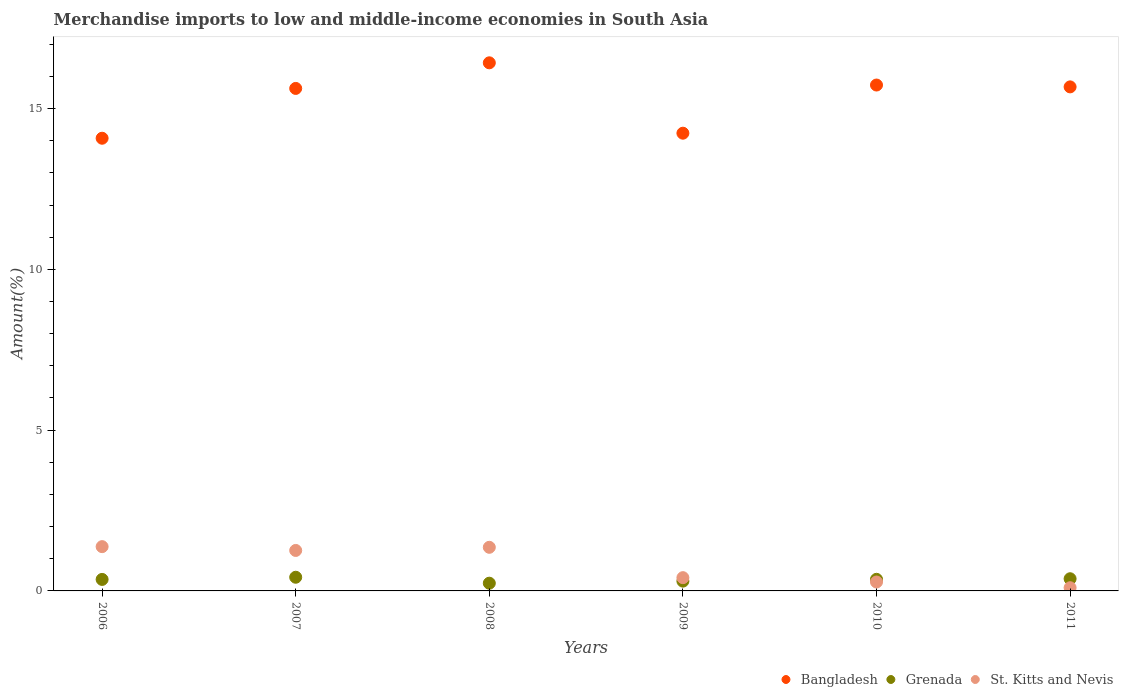Is the number of dotlines equal to the number of legend labels?
Make the answer very short. Yes. What is the percentage of amount earned from merchandise imports in Bangladesh in 2008?
Your answer should be compact. 16.42. Across all years, what is the maximum percentage of amount earned from merchandise imports in St. Kitts and Nevis?
Your response must be concise. 1.38. Across all years, what is the minimum percentage of amount earned from merchandise imports in St. Kitts and Nevis?
Provide a succinct answer. 0.1. In which year was the percentage of amount earned from merchandise imports in Bangladesh maximum?
Provide a succinct answer. 2008. What is the total percentage of amount earned from merchandise imports in Bangladesh in the graph?
Keep it short and to the point. 91.77. What is the difference between the percentage of amount earned from merchandise imports in St. Kitts and Nevis in 2006 and that in 2010?
Offer a very short reply. 1.1. What is the difference between the percentage of amount earned from merchandise imports in Grenada in 2011 and the percentage of amount earned from merchandise imports in St. Kitts and Nevis in 2008?
Keep it short and to the point. -0.98. What is the average percentage of amount earned from merchandise imports in Bangladesh per year?
Offer a very short reply. 15.3. In the year 2011, what is the difference between the percentage of amount earned from merchandise imports in Grenada and percentage of amount earned from merchandise imports in Bangladesh?
Keep it short and to the point. -15.3. In how many years, is the percentage of amount earned from merchandise imports in Grenada greater than 7 %?
Give a very brief answer. 0. What is the ratio of the percentage of amount earned from merchandise imports in St. Kitts and Nevis in 2007 to that in 2011?
Your response must be concise. 12.65. What is the difference between the highest and the second highest percentage of amount earned from merchandise imports in Bangladesh?
Your response must be concise. 0.69. What is the difference between the highest and the lowest percentage of amount earned from merchandise imports in St. Kitts and Nevis?
Provide a succinct answer. 1.28. In how many years, is the percentage of amount earned from merchandise imports in Bangladesh greater than the average percentage of amount earned from merchandise imports in Bangladesh taken over all years?
Give a very brief answer. 4. Is the sum of the percentage of amount earned from merchandise imports in St. Kitts and Nevis in 2006 and 2007 greater than the maximum percentage of amount earned from merchandise imports in Bangladesh across all years?
Your answer should be very brief. No. Is it the case that in every year, the sum of the percentage of amount earned from merchandise imports in St. Kitts and Nevis and percentage of amount earned from merchandise imports in Bangladesh  is greater than the percentage of amount earned from merchandise imports in Grenada?
Offer a very short reply. Yes. Are the values on the major ticks of Y-axis written in scientific E-notation?
Give a very brief answer. No. Does the graph contain any zero values?
Offer a very short reply. No. How many legend labels are there?
Your answer should be compact. 3. How are the legend labels stacked?
Offer a very short reply. Horizontal. What is the title of the graph?
Provide a short and direct response. Merchandise imports to low and middle-income economies in South Asia. What is the label or title of the Y-axis?
Provide a succinct answer. Amount(%). What is the Amount(%) in Bangladesh in 2006?
Ensure brevity in your answer.  14.08. What is the Amount(%) in Grenada in 2006?
Offer a terse response. 0.36. What is the Amount(%) in St. Kitts and Nevis in 2006?
Offer a very short reply. 1.38. What is the Amount(%) in Bangladesh in 2007?
Keep it short and to the point. 15.63. What is the Amount(%) of Grenada in 2007?
Your answer should be very brief. 0.43. What is the Amount(%) of St. Kitts and Nevis in 2007?
Offer a very short reply. 1.26. What is the Amount(%) of Bangladesh in 2008?
Your answer should be very brief. 16.42. What is the Amount(%) of Grenada in 2008?
Ensure brevity in your answer.  0.24. What is the Amount(%) of St. Kitts and Nevis in 2008?
Your answer should be compact. 1.36. What is the Amount(%) in Bangladesh in 2009?
Provide a short and direct response. 14.23. What is the Amount(%) in Grenada in 2009?
Your answer should be very brief. 0.3. What is the Amount(%) of St. Kitts and Nevis in 2009?
Give a very brief answer. 0.41. What is the Amount(%) of Bangladesh in 2010?
Your answer should be very brief. 15.73. What is the Amount(%) of Grenada in 2010?
Provide a short and direct response. 0.36. What is the Amount(%) of St. Kitts and Nevis in 2010?
Provide a succinct answer. 0.28. What is the Amount(%) of Bangladesh in 2011?
Provide a succinct answer. 15.68. What is the Amount(%) in Grenada in 2011?
Provide a succinct answer. 0.38. What is the Amount(%) in St. Kitts and Nevis in 2011?
Provide a short and direct response. 0.1. Across all years, what is the maximum Amount(%) in Bangladesh?
Offer a terse response. 16.42. Across all years, what is the maximum Amount(%) in Grenada?
Provide a short and direct response. 0.43. Across all years, what is the maximum Amount(%) of St. Kitts and Nevis?
Provide a succinct answer. 1.38. Across all years, what is the minimum Amount(%) in Bangladesh?
Keep it short and to the point. 14.08. Across all years, what is the minimum Amount(%) in Grenada?
Your answer should be very brief. 0.24. Across all years, what is the minimum Amount(%) of St. Kitts and Nevis?
Make the answer very short. 0.1. What is the total Amount(%) of Bangladesh in the graph?
Offer a terse response. 91.77. What is the total Amount(%) of Grenada in the graph?
Ensure brevity in your answer.  2.07. What is the total Amount(%) in St. Kitts and Nevis in the graph?
Keep it short and to the point. 4.78. What is the difference between the Amount(%) of Bangladesh in 2006 and that in 2007?
Your answer should be very brief. -1.55. What is the difference between the Amount(%) in Grenada in 2006 and that in 2007?
Your response must be concise. -0.07. What is the difference between the Amount(%) in St. Kitts and Nevis in 2006 and that in 2007?
Make the answer very short. 0.12. What is the difference between the Amount(%) of Bangladesh in 2006 and that in 2008?
Your answer should be compact. -2.35. What is the difference between the Amount(%) of Grenada in 2006 and that in 2008?
Your answer should be very brief. 0.12. What is the difference between the Amount(%) of St. Kitts and Nevis in 2006 and that in 2008?
Provide a short and direct response. 0.02. What is the difference between the Amount(%) in Bangladesh in 2006 and that in 2009?
Give a very brief answer. -0.16. What is the difference between the Amount(%) of Grenada in 2006 and that in 2009?
Your response must be concise. 0.05. What is the difference between the Amount(%) of St. Kitts and Nevis in 2006 and that in 2009?
Give a very brief answer. 0.96. What is the difference between the Amount(%) in Bangladesh in 2006 and that in 2010?
Provide a short and direct response. -1.65. What is the difference between the Amount(%) of Grenada in 2006 and that in 2010?
Your answer should be very brief. -0. What is the difference between the Amount(%) in St. Kitts and Nevis in 2006 and that in 2010?
Provide a succinct answer. 1.1. What is the difference between the Amount(%) of Bangladesh in 2006 and that in 2011?
Give a very brief answer. -1.6. What is the difference between the Amount(%) in Grenada in 2006 and that in 2011?
Your response must be concise. -0.02. What is the difference between the Amount(%) in St. Kitts and Nevis in 2006 and that in 2011?
Your answer should be very brief. 1.28. What is the difference between the Amount(%) in Bangladesh in 2007 and that in 2008?
Your answer should be very brief. -0.8. What is the difference between the Amount(%) of Grenada in 2007 and that in 2008?
Keep it short and to the point. 0.18. What is the difference between the Amount(%) in St. Kitts and Nevis in 2007 and that in 2008?
Your response must be concise. -0.1. What is the difference between the Amount(%) in Bangladesh in 2007 and that in 2009?
Your answer should be compact. 1.39. What is the difference between the Amount(%) in Grenada in 2007 and that in 2009?
Make the answer very short. 0.12. What is the difference between the Amount(%) in St. Kitts and Nevis in 2007 and that in 2009?
Your answer should be very brief. 0.85. What is the difference between the Amount(%) of Bangladesh in 2007 and that in 2010?
Your response must be concise. -0.11. What is the difference between the Amount(%) of Grenada in 2007 and that in 2010?
Provide a short and direct response. 0.06. What is the difference between the Amount(%) in St. Kitts and Nevis in 2007 and that in 2010?
Your answer should be compact. 0.98. What is the difference between the Amount(%) in Bangladesh in 2007 and that in 2011?
Provide a short and direct response. -0.05. What is the difference between the Amount(%) of Grenada in 2007 and that in 2011?
Make the answer very short. 0.05. What is the difference between the Amount(%) in St. Kitts and Nevis in 2007 and that in 2011?
Provide a short and direct response. 1.16. What is the difference between the Amount(%) of Bangladesh in 2008 and that in 2009?
Your response must be concise. 2.19. What is the difference between the Amount(%) in Grenada in 2008 and that in 2009?
Your response must be concise. -0.06. What is the difference between the Amount(%) of St. Kitts and Nevis in 2008 and that in 2009?
Offer a terse response. 0.94. What is the difference between the Amount(%) of Bangladesh in 2008 and that in 2010?
Offer a terse response. 0.69. What is the difference between the Amount(%) of Grenada in 2008 and that in 2010?
Your answer should be very brief. -0.12. What is the difference between the Amount(%) in St. Kitts and Nevis in 2008 and that in 2010?
Offer a very short reply. 1.08. What is the difference between the Amount(%) of Bangladesh in 2008 and that in 2011?
Ensure brevity in your answer.  0.75. What is the difference between the Amount(%) in Grenada in 2008 and that in 2011?
Your answer should be very brief. -0.14. What is the difference between the Amount(%) of St. Kitts and Nevis in 2008 and that in 2011?
Keep it short and to the point. 1.26. What is the difference between the Amount(%) of Bangladesh in 2009 and that in 2010?
Make the answer very short. -1.5. What is the difference between the Amount(%) of Grenada in 2009 and that in 2010?
Your answer should be compact. -0.06. What is the difference between the Amount(%) of St. Kitts and Nevis in 2009 and that in 2010?
Your answer should be very brief. 0.13. What is the difference between the Amount(%) of Bangladesh in 2009 and that in 2011?
Ensure brevity in your answer.  -1.44. What is the difference between the Amount(%) of Grenada in 2009 and that in 2011?
Ensure brevity in your answer.  -0.07. What is the difference between the Amount(%) of St. Kitts and Nevis in 2009 and that in 2011?
Make the answer very short. 0.31. What is the difference between the Amount(%) in Bangladesh in 2010 and that in 2011?
Offer a terse response. 0.06. What is the difference between the Amount(%) of Grenada in 2010 and that in 2011?
Your answer should be very brief. -0.02. What is the difference between the Amount(%) of St. Kitts and Nevis in 2010 and that in 2011?
Provide a short and direct response. 0.18. What is the difference between the Amount(%) in Bangladesh in 2006 and the Amount(%) in Grenada in 2007?
Ensure brevity in your answer.  13.65. What is the difference between the Amount(%) of Bangladesh in 2006 and the Amount(%) of St. Kitts and Nevis in 2007?
Keep it short and to the point. 12.82. What is the difference between the Amount(%) in Grenada in 2006 and the Amount(%) in St. Kitts and Nevis in 2007?
Ensure brevity in your answer.  -0.9. What is the difference between the Amount(%) in Bangladesh in 2006 and the Amount(%) in Grenada in 2008?
Offer a terse response. 13.84. What is the difference between the Amount(%) in Bangladesh in 2006 and the Amount(%) in St. Kitts and Nevis in 2008?
Offer a very short reply. 12.72. What is the difference between the Amount(%) of Grenada in 2006 and the Amount(%) of St. Kitts and Nevis in 2008?
Your answer should be very brief. -1. What is the difference between the Amount(%) in Bangladesh in 2006 and the Amount(%) in Grenada in 2009?
Offer a very short reply. 13.77. What is the difference between the Amount(%) in Bangladesh in 2006 and the Amount(%) in St. Kitts and Nevis in 2009?
Your answer should be very brief. 13.67. What is the difference between the Amount(%) in Grenada in 2006 and the Amount(%) in St. Kitts and Nevis in 2009?
Offer a terse response. -0.05. What is the difference between the Amount(%) of Bangladesh in 2006 and the Amount(%) of Grenada in 2010?
Offer a very short reply. 13.72. What is the difference between the Amount(%) of Bangladesh in 2006 and the Amount(%) of St. Kitts and Nevis in 2010?
Offer a very short reply. 13.8. What is the difference between the Amount(%) of Grenada in 2006 and the Amount(%) of St. Kitts and Nevis in 2010?
Your response must be concise. 0.08. What is the difference between the Amount(%) of Bangladesh in 2006 and the Amount(%) of Grenada in 2011?
Provide a short and direct response. 13.7. What is the difference between the Amount(%) of Bangladesh in 2006 and the Amount(%) of St. Kitts and Nevis in 2011?
Your answer should be very brief. 13.98. What is the difference between the Amount(%) of Grenada in 2006 and the Amount(%) of St. Kitts and Nevis in 2011?
Your response must be concise. 0.26. What is the difference between the Amount(%) in Bangladesh in 2007 and the Amount(%) in Grenada in 2008?
Provide a short and direct response. 15.39. What is the difference between the Amount(%) of Bangladesh in 2007 and the Amount(%) of St. Kitts and Nevis in 2008?
Give a very brief answer. 14.27. What is the difference between the Amount(%) of Grenada in 2007 and the Amount(%) of St. Kitts and Nevis in 2008?
Keep it short and to the point. -0.93. What is the difference between the Amount(%) of Bangladesh in 2007 and the Amount(%) of Grenada in 2009?
Your answer should be compact. 15.32. What is the difference between the Amount(%) of Bangladesh in 2007 and the Amount(%) of St. Kitts and Nevis in 2009?
Your answer should be very brief. 15.22. What is the difference between the Amount(%) in Grenada in 2007 and the Amount(%) in St. Kitts and Nevis in 2009?
Offer a terse response. 0.01. What is the difference between the Amount(%) of Bangladesh in 2007 and the Amount(%) of Grenada in 2010?
Offer a terse response. 15.27. What is the difference between the Amount(%) of Bangladesh in 2007 and the Amount(%) of St. Kitts and Nevis in 2010?
Your response must be concise. 15.35. What is the difference between the Amount(%) in Grenada in 2007 and the Amount(%) in St. Kitts and Nevis in 2010?
Your answer should be very brief. 0.15. What is the difference between the Amount(%) of Bangladesh in 2007 and the Amount(%) of Grenada in 2011?
Offer a terse response. 15.25. What is the difference between the Amount(%) in Bangladesh in 2007 and the Amount(%) in St. Kitts and Nevis in 2011?
Your answer should be very brief. 15.53. What is the difference between the Amount(%) in Grenada in 2007 and the Amount(%) in St. Kitts and Nevis in 2011?
Provide a succinct answer. 0.33. What is the difference between the Amount(%) of Bangladesh in 2008 and the Amount(%) of Grenada in 2009?
Provide a short and direct response. 16.12. What is the difference between the Amount(%) in Bangladesh in 2008 and the Amount(%) in St. Kitts and Nevis in 2009?
Give a very brief answer. 16.01. What is the difference between the Amount(%) of Grenada in 2008 and the Amount(%) of St. Kitts and Nevis in 2009?
Provide a short and direct response. -0.17. What is the difference between the Amount(%) of Bangladesh in 2008 and the Amount(%) of Grenada in 2010?
Keep it short and to the point. 16.06. What is the difference between the Amount(%) in Bangladesh in 2008 and the Amount(%) in St. Kitts and Nevis in 2010?
Provide a short and direct response. 16.15. What is the difference between the Amount(%) of Grenada in 2008 and the Amount(%) of St. Kitts and Nevis in 2010?
Provide a succinct answer. -0.04. What is the difference between the Amount(%) in Bangladesh in 2008 and the Amount(%) in Grenada in 2011?
Give a very brief answer. 16.04. What is the difference between the Amount(%) in Bangladesh in 2008 and the Amount(%) in St. Kitts and Nevis in 2011?
Your answer should be very brief. 16.32. What is the difference between the Amount(%) in Grenada in 2008 and the Amount(%) in St. Kitts and Nevis in 2011?
Ensure brevity in your answer.  0.14. What is the difference between the Amount(%) of Bangladesh in 2009 and the Amount(%) of Grenada in 2010?
Ensure brevity in your answer.  13.87. What is the difference between the Amount(%) in Bangladesh in 2009 and the Amount(%) in St. Kitts and Nevis in 2010?
Your response must be concise. 13.96. What is the difference between the Amount(%) in Grenada in 2009 and the Amount(%) in St. Kitts and Nevis in 2010?
Provide a succinct answer. 0.03. What is the difference between the Amount(%) of Bangladesh in 2009 and the Amount(%) of Grenada in 2011?
Your answer should be compact. 13.86. What is the difference between the Amount(%) in Bangladesh in 2009 and the Amount(%) in St. Kitts and Nevis in 2011?
Make the answer very short. 14.14. What is the difference between the Amount(%) of Grenada in 2009 and the Amount(%) of St. Kitts and Nevis in 2011?
Provide a short and direct response. 0.2. What is the difference between the Amount(%) of Bangladesh in 2010 and the Amount(%) of Grenada in 2011?
Ensure brevity in your answer.  15.35. What is the difference between the Amount(%) of Bangladesh in 2010 and the Amount(%) of St. Kitts and Nevis in 2011?
Ensure brevity in your answer.  15.63. What is the difference between the Amount(%) in Grenada in 2010 and the Amount(%) in St. Kitts and Nevis in 2011?
Your response must be concise. 0.26. What is the average Amount(%) in Bangladesh per year?
Ensure brevity in your answer.  15.3. What is the average Amount(%) of Grenada per year?
Provide a succinct answer. 0.34. What is the average Amount(%) in St. Kitts and Nevis per year?
Keep it short and to the point. 0.8. In the year 2006, what is the difference between the Amount(%) in Bangladesh and Amount(%) in Grenada?
Provide a short and direct response. 13.72. In the year 2006, what is the difference between the Amount(%) of Bangladesh and Amount(%) of St. Kitts and Nevis?
Offer a terse response. 12.7. In the year 2006, what is the difference between the Amount(%) of Grenada and Amount(%) of St. Kitts and Nevis?
Your response must be concise. -1.02. In the year 2007, what is the difference between the Amount(%) in Bangladesh and Amount(%) in Grenada?
Offer a very short reply. 15.2. In the year 2007, what is the difference between the Amount(%) in Bangladesh and Amount(%) in St. Kitts and Nevis?
Make the answer very short. 14.37. In the year 2007, what is the difference between the Amount(%) in Grenada and Amount(%) in St. Kitts and Nevis?
Offer a terse response. -0.83. In the year 2008, what is the difference between the Amount(%) in Bangladesh and Amount(%) in Grenada?
Ensure brevity in your answer.  16.18. In the year 2008, what is the difference between the Amount(%) in Bangladesh and Amount(%) in St. Kitts and Nevis?
Keep it short and to the point. 15.07. In the year 2008, what is the difference between the Amount(%) in Grenada and Amount(%) in St. Kitts and Nevis?
Ensure brevity in your answer.  -1.12. In the year 2009, what is the difference between the Amount(%) of Bangladesh and Amount(%) of Grenada?
Ensure brevity in your answer.  13.93. In the year 2009, what is the difference between the Amount(%) in Bangladesh and Amount(%) in St. Kitts and Nevis?
Your response must be concise. 13.82. In the year 2009, what is the difference between the Amount(%) in Grenada and Amount(%) in St. Kitts and Nevis?
Give a very brief answer. -0.11. In the year 2010, what is the difference between the Amount(%) of Bangladesh and Amount(%) of Grenada?
Ensure brevity in your answer.  15.37. In the year 2010, what is the difference between the Amount(%) of Bangladesh and Amount(%) of St. Kitts and Nevis?
Provide a succinct answer. 15.46. In the year 2010, what is the difference between the Amount(%) in Grenada and Amount(%) in St. Kitts and Nevis?
Provide a short and direct response. 0.08. In the year 2011, what is the difference between the Amount(%) of Bangladesh and Amount(%) of Grenada?
Offer a terse response. 15.3. In the year 2011, what is the difference between the Amount(%) in Bangladesh and Amount(%) in St. Kitts and Nevis?
Your answer should be very brief. 15.58. In the year 2011, what is the difference between the Amount(%) in Grenada and Amount(%) in St. Kitts and Nevis?
Keep it short and to the point. 0.28. What is the ratio of the Amount(%) of Bangladesh in 2006 to that in 2007?
Provide a short and direct response. 0.9. What is the ratio of the Amount(%) of Grenada in 2006 to that in 2007?
Make the answer very short. 0.84. What is the ratio of the Amount(%) in St. Kitts and Nevis in 2006 to that in 2007?
Your answer should be compact. 1.09. What is the ratio of the Amount(%) in Bangladesh in 2006 to that in 2008?
Make the answer very short. 0.86. What is the ratio of the Amount(%) of Grenada in 2006 to that in 2008?
Keep it short and to the point. 1.49. What is the ratio of the Amount(%) of St. Kitts and Nevis in 2006 to that in 2008?
Offer a very short reply. 1.02. What is the ratio of the Amount(%) in Bangladesh in 2006 to that in 2009?
Offer a very short reply. 0.99. What is the ratio of the Amount(%) in Grenada in 2006 to that in 2009?
Your response must be concise. 1.17. What is the ratio of the Amount(%) in St. Kitts and Nevis in 2006 to that in 2009?
Offer a very short reply. 3.34. What is the ratio of the Amount(%) in Bangladesh in 2006 to that in 2010?
Provide a short and direct response. 0.89. What is the ratio of the Amount(%) of Grenada in 2006 to that in 2010?
Provide a short and direct response. 0.99. What is the ratio of the Amount(%) in St. Kitts and Nevis in 2006 to that in 2010?
Your answer should be very brief. 4.97. What is the ratio of the Amount(%) of Bangladesh in 2006 to that in 2011?
Your answer should be very brief. 0.9. What is the ratio of the Amount(%) of Grenada in 2006 to that in 2011?
Your answer should be compact. 0.94. What is the ratio of the Amount(%) in St. Kitts and Nevis in 2006 to that in 2011?
Make the answer very short. 13.84. What is the ratio of the Amount(%) of Bangladesh in 2007 to that in 2008?
Your response must be concise. 0.95. What is the ratio of the Amount(%) in Grenada in 2007 to that in 2008?
Keep it short and to the point. 1.77. What is the ratio of the Amount(%) of St. Kitts and Nevis in 2007 to that in 2008?
Your answer should be very brief. 0.93. What is the ratio of the Amount(%) in Bangladesh in 2007 to that in 2009?
Ensure brevity in your answer.  1.1. What is the ratio of the Amount(%) in Grenada in 2007 to that in 2009?
Keep it short and to the point. 1.4. What is the ratio of the Amount(%) of St. Kitts and Nevis in 2007 to that in 2009?
Give a very brief answer. 3.05. What is the ratio of the Amount(%) in Bangladesh in 2007 to that in 2010?
Provide a succinct answer. 0.99. What is the ratio of the Amount(%) in Grenada in 2007 to that in 2010?
Offer a terse response. 1.18. What is the ratio of the Amount(%) in St. Kitts and Nevis in 2007 to that in 2010?
Your answer should be compact. 4.54. What is the ratio of the Amount(%) in Grenada in 2007 to that in 2011?
Your answer should be compact. 1.12. What is the ratio of the Amount(%) in St. Kitts and Nevis in 2007 to that in 2011?
Your response must be concise. 12.65. What is the ratio of the Amount(%) of Bangladesh in 2008 to that in 2009?
Provide a short and direct response. 1.15. What is the ratio of the Amount(%) in Grenada in 2008 to that in 2009?
Make the answer very short. 0.79. What is the ratio of the Amount(%) of St. Kitts and Nevis in 2008 to that in 2009?
Provide a short and direct response. 3.29. What is the ratio of the Amount(%) in Bangladesh in 2008 to that in 2010?
Offer a terse response. 1.04. What is the ratio of the Amount(%) in Grenada in 2008 to that in 2010?
Provide a succinct answer. 0.66. What is the ratio of the Amount(%) of St. Kitts and Nevis in 2008 to that in 2010?
Make the answer very short. 4.89. What is the ratio of the Amount(%) of Bangladesh in 2008 to that in 2011?
Offer a terse response. 1.05. What is the ratio of the Amount(%) of Grenada in 2008 to that in 2011?
Give a very brief answer. 0.63. What is the ratio of the Amount(%) of St. Kitts and Nevis in 2008 to that in 2011?
Give a very brief answer. 13.63. What is the ratio of the Amount(%) in Bangladesh in 2009 to that in 2010?
Your answer should be compact. 0.9. What is the ratio of the Amount(%) in Grenada in 2009 to that in 2010?
Offer a very short reply. 0.84. What is the ratio of the Amount(%) in St. Kitts and Nevis in 2009 to that in 2010?
Provide a short and direct response. 1.49. What is the ratio of the Amount(%) in Bangladesh in 2009 to that in 2011?
Keep it short and to the point. 0.91. What is the ratio of the Amount(%) of Grenada in 2009 to that in 2011?
Offer a terse response. 0.8. What is the ratio of the Amount(%) in St. Kitts and Nevis in 2009 to that in 2011?
Provide a succinct answer. 4.14. What is the ratio of the Amount(%) in Bangladesh in 2010 to that in 2011?
Your answer should be very brief. 1. What is the ratio of the Amount(%) in Grenada in 2010 to that in 2011?
Make the answer very short. 0.95. What is the ratio of the Amount(%) of St. Kitts and Nevis in 2010 to that in 2011?
Make the answer very short. 2.79. What is the difference between the highest and the second highest Amount(%) of Bangladesh?
Your answer should be very brief. 0.69. What is the difference between the highest and the second highest Amount(%) in Grenada?
Your response must be concise. 0.05. What is the difference between the highest and the second highest Amount(%) of St. Kitts and Nevis?
Your response must be concise. 0.02. What is the difference between the highest and the lowest Amount(%) of Bangladesh?
Offer a terse response. 2.35. What is the difference between the highest and the lowest Amount(%) in Grenada?
Provide a short and direct response. 0.18. What is the difference between the highest and the lowest Amount(%) in St. Kitts and Nevis?
Your response must be concise. 1.28. 